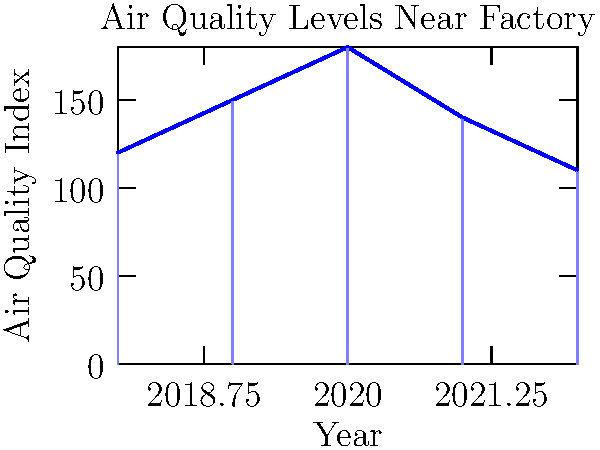The graph shows the Air Quality Index (AQI) near a factory over five years. In which year was the air quality the worst, and what might have caused this peak? Step 1: Analyze the graph to identify the highest point, which represents the worst air quality.
Step 2: The highest bar in the graph corresponds to the year 2020, with an AQI of 180.
Step 3: Consider potential causes for the peak in 2020:
   - Increased factory production
   - Changes in environmental regulations
   - Possible reduction in air quality monitoring due to the COVID-19 pandemic
Step 4: Note the trend before and after 2020:
   - AQI increased from 2018 to 2020
   - AQI decreased from 2020 to 2022
Step 5: Relate to the persona: As a single mother living near the factory, this peak in 2020 might have significantly impacted the health of her children.
Answer: 2020; possible causes include increased production, relaxed regulations, or reduced monitoring due to COVID-19. 